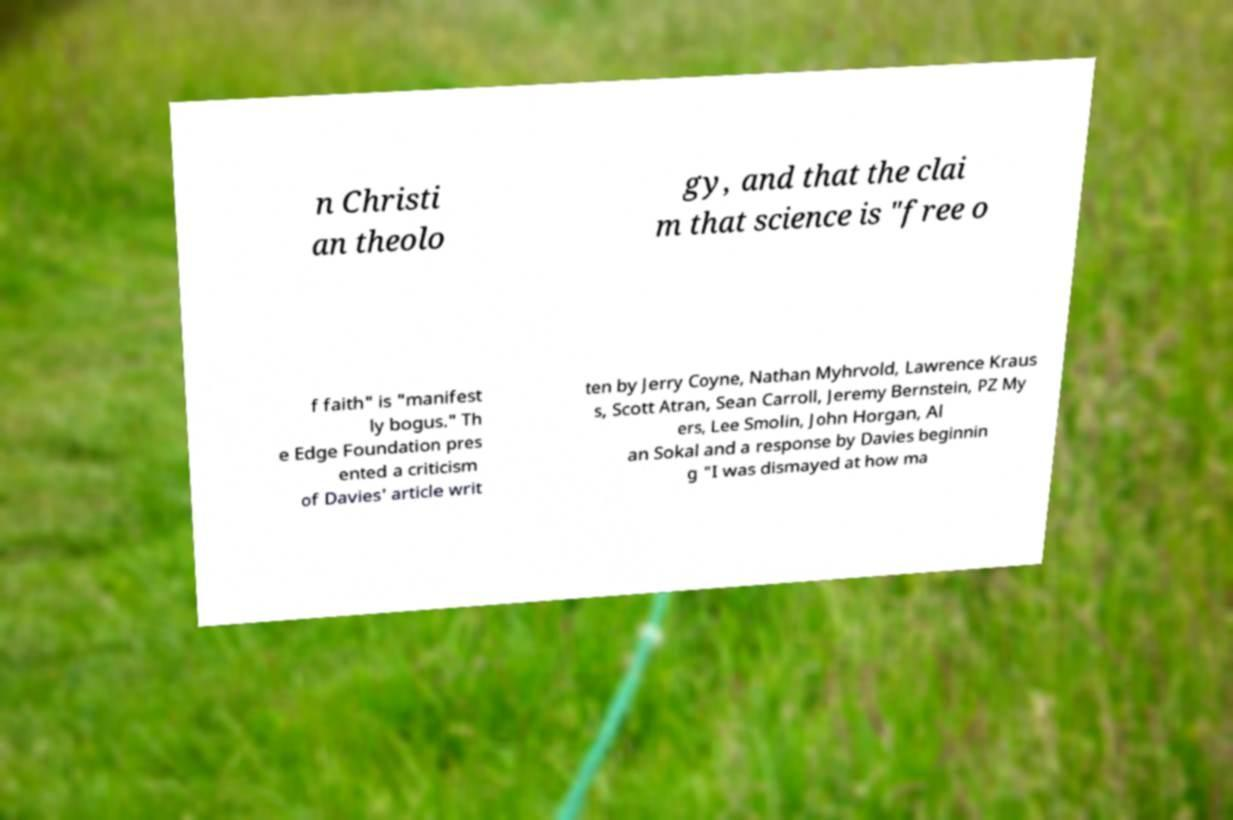Can you accurately transcribe the text from the provided image for me? n Christi an theolo gy, and that the clai m that science is "free o f faith" is "manifest ly bogus." Th e Edge Foundation pres ented a criticism of Davies' article writ ten by Jerry Coyne, Nathan Myhrvold, Lawrence Kraus s, Scott Atran, Sean Carroll, Jeremy Bernstein, PZ My ers, Lee Smolin, John Horgan, Al an Sokal and a response by Davies beginnin g "I was dismayed at how ma 